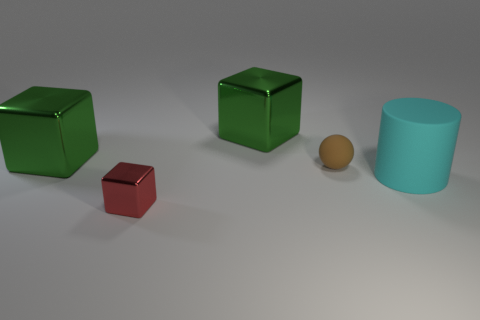Add 4 cyan matte balls. How many objects exist? 9 Subtract all blocks. How many objects are left? 2 Subtract all large shiny cubes. Subtract all brown rubber balls. How many objects are left? 2 Add 3 tiny objects. How many tiny objects are left? 5 Add 2 rubber balls. How many rubber balls exist? 3 Subtract 0 cyan spheres. How many objects are left? 5 